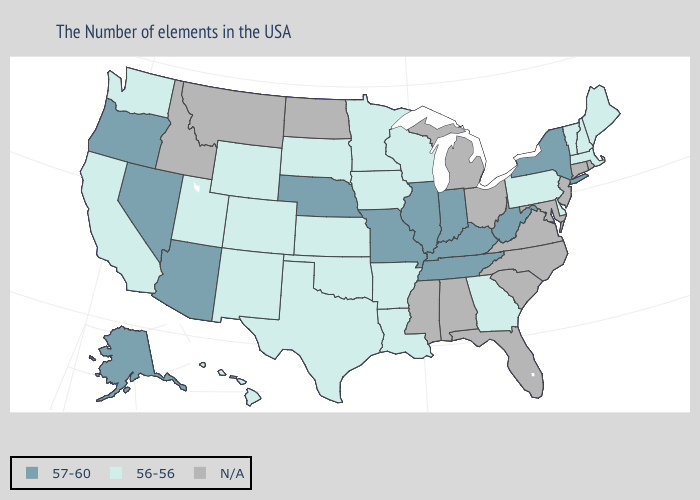Which states have the highest value in the USA?
Be succinct. New York, West Virginia, Kentucky, Indiana, Tennessee, Illinois, Missouri, Nebraska, Arizona, Nevada, Oregon, Alaska. Name the states that have a value in the range N/A?
Short answer required. Rhode Island, Connecticut, New Jersey, Maryland, Virginia, North Carolina, South Carolina, Ohio, Florida, Michigan, Alabama, Mississippi, North Dakota, Montana, Idaho. What is the value of Illinois?
Quick response, please. 57-60. What is the highest value in states that border Illinois?
Write a very short answer. 57-60. Which states have the highest value in the USA?
Give a very brief answer. New York, West Virginia, Kentucky, Indiana, Tennessee, Illinois, Missouri, Nebraska, Arizona, Nevada, Oregon, Alaska. Among the states that border Ohio , does Pennsylvania have the highest value?
Concise answer only. No. Among the states that border New Mexico , which have the lowest value?
Quick response, please. Oklahoma, Texas, Colorado, Utah. What is the highest value in the West ?
Answer briefly. 57-60. How many symbols are there in the legend?
Quick response, please. 3. Does Vermont have the highest value in the USA?
Give a very brief answer. No. What is the value of Montana?
Short answer required. N/A. What is the highest value in states that border Iowa?
Give a very brief answer. 57-60. Does West Virginia have the highest value in the South?
Short answer required. Yes. 